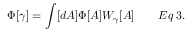Convert formula to latex. <formula><loc_0><loc_0><loc_500><loc_500>\Phi [ \gamma ] = \int [ d A ] \Phi [ A ] W _ { \gamma } [ A ] \quad E q \, 3 .</formula> 